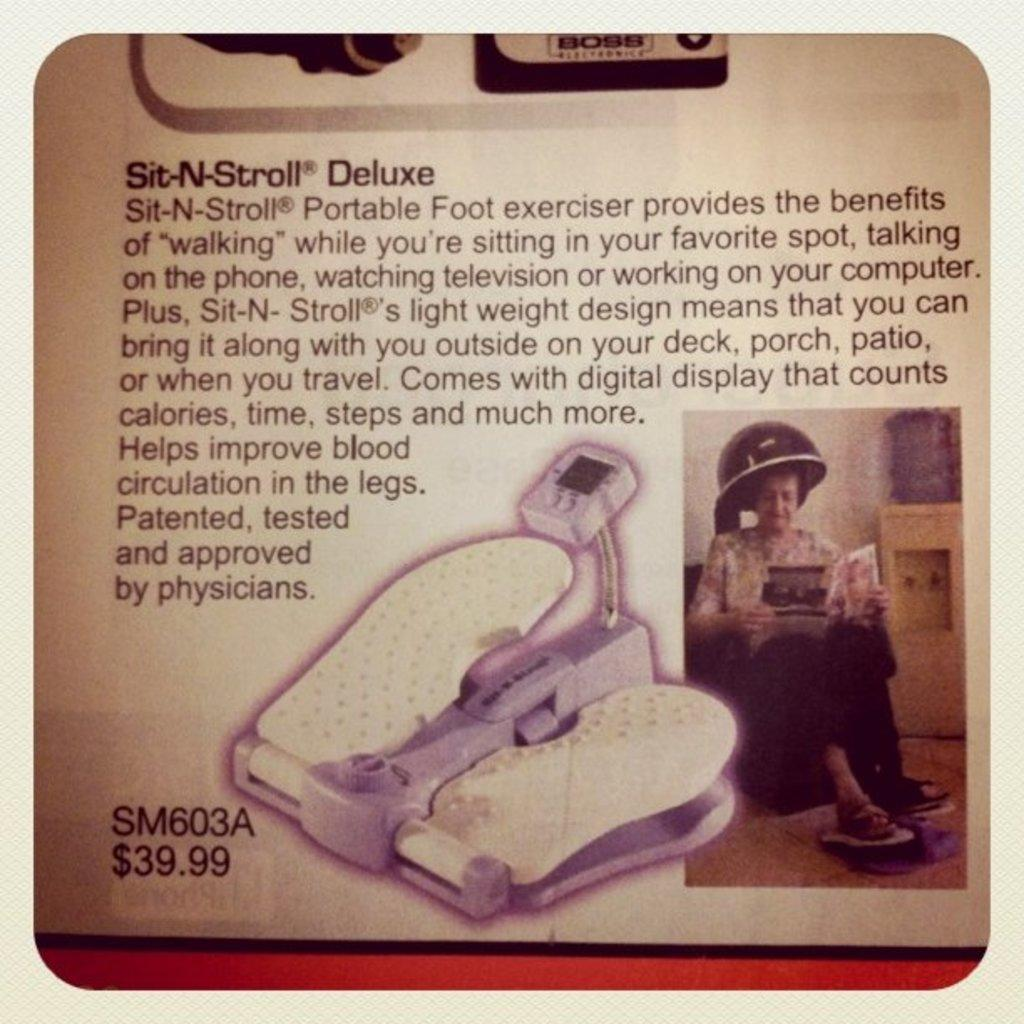What is the main subject of the image? The main subject of the image is a picture of a newspaper article. What type of content can be found in the newspaper article? The newspaper article contains text and an image. What song is being sung in the background of the image? There is no song or audio present in the image; it only contains a picture of a newspaper article. 